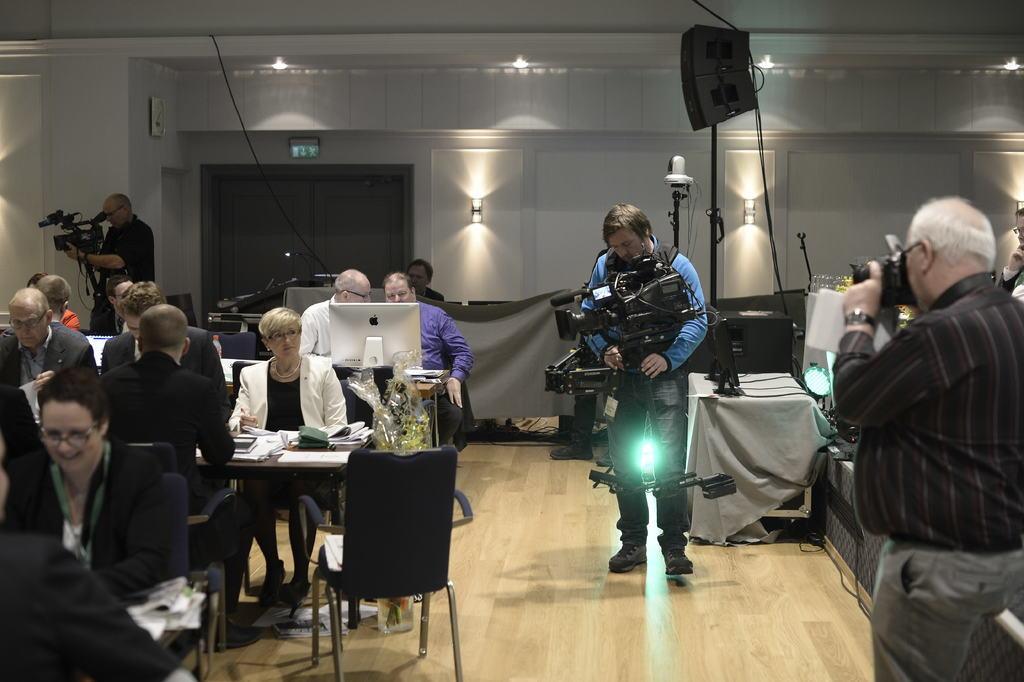Can you describe this image briefly? In this picture we can see a group of people siting on chairs in front of tables and there are three people who are standing and capturing with their cameras, there is a door behind everybody, there is a speaker on the right side 